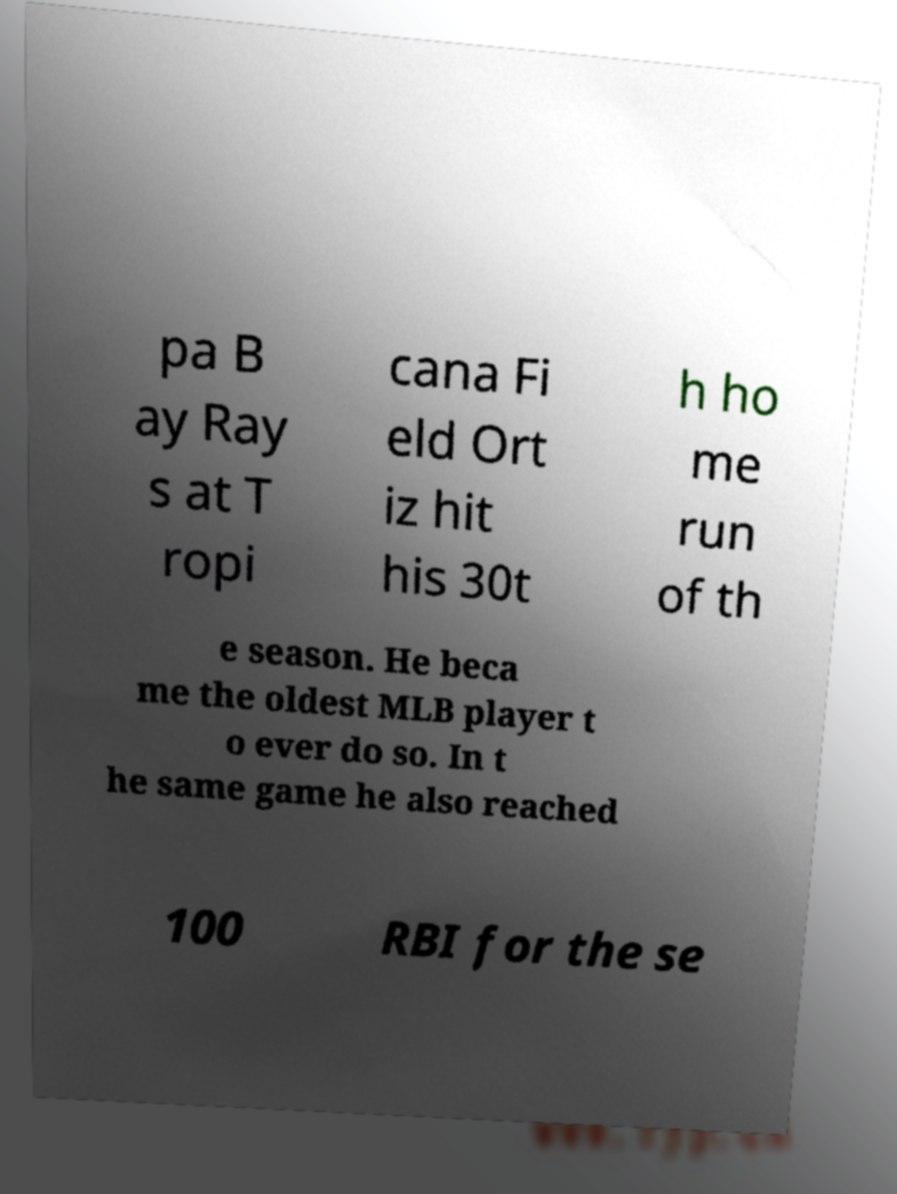What messages or text are displayed in this image? I need them in a readable, typed format. pa B ay Ray s at T ropi cana Fi eld Ort iz hit his 30t h ho me run of th e season. He beca me the oldest MLB player t o ever do so. In t he same game he also reached 100 RBI for the se 